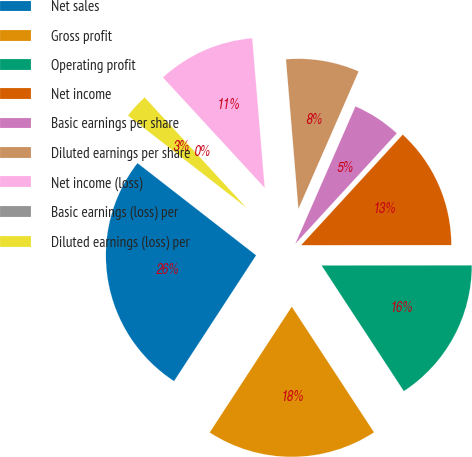Convert chart. <chart><loc_0><loc_0><loc_500><loc_500><pie_chart><fcel>Net sales<fcel>Gross profit<fcel>Operating profit<fcel>Net income<fcel>Basic earnings per share<fcel>Diluted earnings per share<fcel>Net income (loss)<fcel>Basic earnings (loss) per<fcel>Diluted earnings (loss) per<nl><fcel>26.32%<fcel>18.42%<fcel>15.79%<fcel>13.16%<fcel>5.26%<fcel>7.89%<fcel>10.53%<fcel>0.0%<fcel>2.63%<nl></chart> 